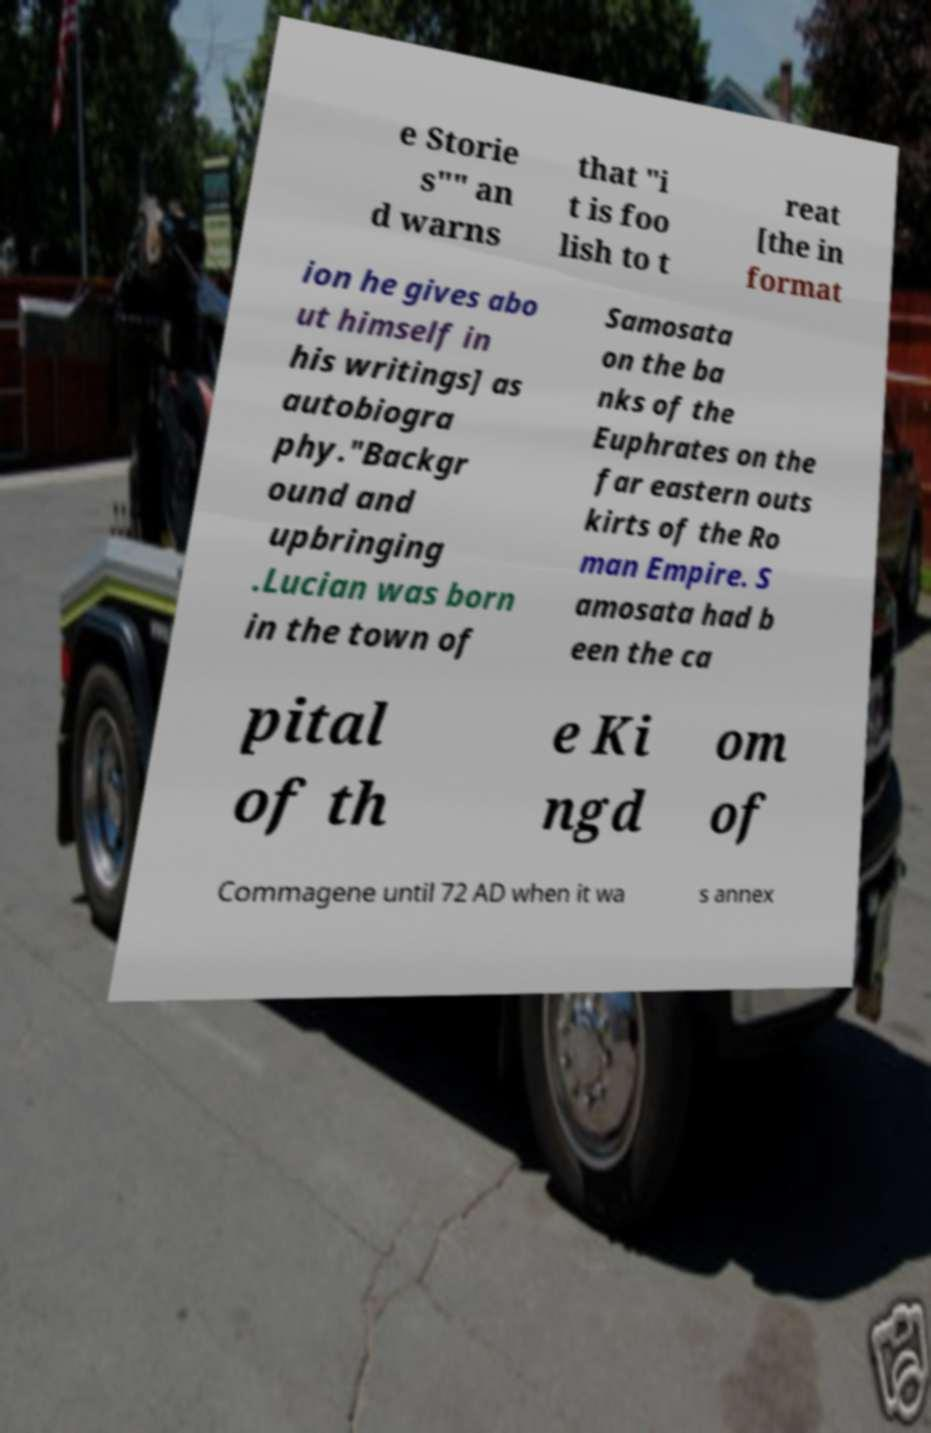Could you assist in decoding the text presented in this image and type it out clearly? e Storie s"" an d warns that "i t is foo lish to t reat [the in format ion he gives abo ut himself in his writings] as autobiogra phy."Backgr ound and upbringing .Lucian was born in the town of Samosata on the ba nks of the Euphrates on the far eastern outs kirts of the Ro man Empire. S amosata had b een the ca pital of th e Ki ngd om of Commagene until 72 AD when it wa s annex 